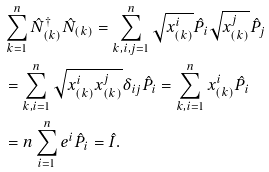Convert formula to latex. <formula><loc_0><loc_0><loc_500><loc_500>& \sum _ { k = 1 } ^ { n } \hat { N } _ { ( k ) } ^ { \dagger } \hat { N } _ { ( k ) } = \sum _ { k , i , j = 1 } ^ { n } \sqrt { x _ { ( k ) } ^ { i } } \hat { P } _ { i } \sqrt { x _ { ( k ) } ^ { j } } \hat { P } _ { j } \\ & = \sum _ { k , i = 1 } ^ { n } \sqrt { x _ { ( k ) } ^ { i } x _ { ( k ) } ^ { j } } \delta _ { i j } \hat { P } _ { i } = \sum _ { k , i = 1 } ^ { n } x _ { ( k ) } ^ { i } \hat { P } _ { i } \\ & = n \sum _ { i = 1 } ^ { n } e ^ { i } \hat { P } _ { i } = \hat { I } .</formula> 